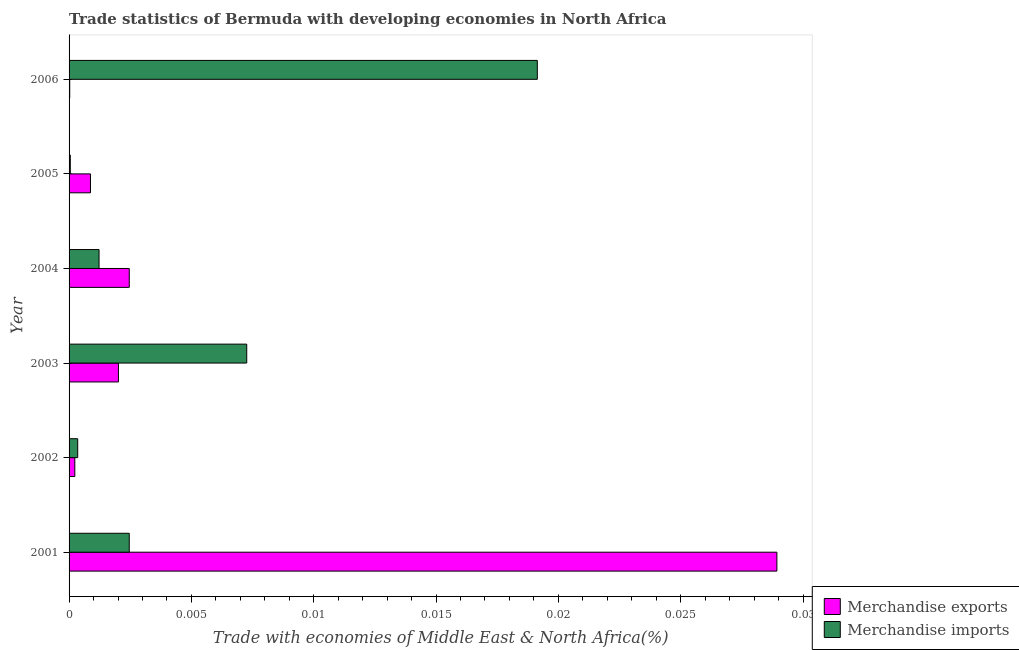How many different coloured bars are there?
Provide a short and direct response. 2. How many groups of bars are there?
Make the answer very short. 6. What is the label of the 4th group of bars from the top?
Your response must be concise. 2003. In how many cases, is the number of bars for a given year not equal to the number of legend labels?
Keep it short and to the point. 0. What is the merchandise imports in 2002?
Your answer should be compact. 0. Across all years, what is the maximum merchandise imports?
Your response must be concise. 0.02. Across all years, what is the minimum merchandise exports?
Your response must be concise. 2.670901782509311e-5. In which year was the merchandise exports minimum?
Your answer should be compact. 2006. What is the total merchandise exports in the graph?
Your response must be concise. 0.03. What is the difference between the merchandise exports in 2001 and that in 2003?
Provide a short and direct response. 0.03. What is the difference between the merchandise exports in 2001 and the merchandise imports in 2005?
Your answer should be compact. 0.03. What is the average merchandise imports per year?
Your response must be concise. 0.01. In the year 2003, what is the difference between the merchandise exports and merchandise imports?
Offer a very short reply. -0.01. In how many years, is the merchandise imports greater than 0.005 %?
Offer a very short reply. 2. What is the ratio of the merchandise imports in 2002 to that in 2006?
Provide a short and direct response. 0.02. Is the merchandise exports in 2002 less than that in 2006?
Ensure brevity in your answer.  No. Is the difference between the merchandise imports in 2004 and 2005 greater than the difference between the merchandise exports in 2004 and 2005?
Offer a terse response. No. What is the difference between the highest and the second highest merchandise imports?
Make the answer very short. 0.01. What is the difference between the highest and the lowest merchandise imports?
Provide a succinct answer. 0.02. In how many years, is the merchandise exports greater than the average merchandise exports taken over all years?
Keep it short and to the point. 1. How many bars are there?
Keep it short and to the point. 12. Are all the bars in the graph horizontal?
Your answer should be compact. Yes. How many years are there in the graph?
Ensure brevity in your answer.  6. What is the difference between two consecutive major ticks on the X-axis?
Provide a succinct answer. 0.01. Does the graph contain grids?
Provide a succinct answer. No. Where does the legend appear in the graph?
Offer a very short reply. Bottom right. What is the title of the graph?
Ensure brevity in your answer.  Trade statistics of Bermuda with developing economies in North Africa. Does "State government" appear as one of the legend labels in the graph?
Make the answer very short. No. What is the label or title of the X-axis?
Offer a terse response. Trade with economies of Middle East & North Africa(%). What is the Trade with economies of Middle East & North Africa(%) in Merchandise exports in 2001?
Provide a short and direct response. 0.03. What is the Trade with economies of Middle East & North Africa(%) of Merchandise imports in 2001?
Your response must be concise. 0. What is the Trade with economies of Middle East & North Africa(%) in Merchandise exports in 2002?
Offer a terse response. 0. What is the Trade with economies of Middle East & North Africa(%) of Merchandise imports in 2002?
Keep it short and to the point. 0. What is the Trade with economies of Middle East & North Africa(%) of Merchandise exports in 2003?
Ensure brevity in your answer.  0. What is the Trade with economies of Middle East & North Africa(%) in Merchandise imports in 2003?
Your answer should be very brief. 0.01. What is the Trade with economies of Middle East & North Africa(%) in Merchandise exports in 2004?
Offer a terse response. 0. What is the Trade with economies of Middle East & North Africa(%) of Merchandise imports in 2004?
Keep it short and to the point. 0. What is the Trade with economies of Middle East & North Africa(%) in Merchandise exports in 2005?
Your answer should be compact. 0. What is the Trade with economies of Middle East & North Africa(%) of Merchandise imports in 2005?
Make the answer very short. 4.991405699987221e-5. What is the Trade with economies of Middle East & North Africa(%) of Merchandise exports in 2006?
Your answer should be compact. 2.670901782509311e-5. What is the Trade with economies of Middle East & North Africa(%) in Merchandise imports in 2006?
Your answer should be very brief. 0.02. Across all years, what is the maximum Trade with economies of Middle East & North Africa(%) in Merchandise exports?
Your answer should be very brief. 0.03. Across all years, what is the maximum Trade with economies of Middle East & North Africa(%) of Merchandise imports?
Your answer should be compact. 0.02. Across all years, what is the minimum Trade with economies of Middle East & North Africa(%) of Merchandise exports?
Your answer should be very brief. 2.670901782509311e-5. Across all years, what is the minimum Trade with economies of Middle East & North Africa(%) of Merchandise imports?
Keep it short and to the point. 4.991405699987221e-5. What is the total Trade with economies of Middle East & North Africa(%) in Merchandise exports in the graph?
Offer a very short reply. 0.03. What is the total Trade with economies of Middle East & North Africa(%) in Merchandise imports in the graph?
Provide a short and direct response. 0.03. What is the difference between the Trade with economies of Middle East & North Africa(%) of Merchandise exports in 2001 and that in 2002?
Give a very brief answer. 0.03. What is the difference between the Trade with economies of Middle East & North Africa(%) of Merchandise imports in 2001 and that in 2002?
Keep it short and to the point. 0. What is the difference between the Trade with economies of Middle East & North Africa(%) of Merchandise exports in 2001 and that in 2003?
Your answer should be very brief. 0.03. What is the difference between the Trade with economies of Middle East & North Africa(%) of Merchandise imports in 2001 and that in 2003?
Give a very brief answer. -0. What is the difference between the Trade with economies of Middle East & North Africa(%) in Merchandise exports in 2001 and that in 2004?
Keep it short and to the point. 0.03. What is the difference between the Trade with economies of Middle East & North Africa(%) of Merchandise imports in 2001 and that in 2004?
Keep it short and to the point. 0. What is the difference between the Trade with economies of Middle East & North Africa(%) of Merchandise exports in 2001 and that in 2005?
Keep it short and to the point. 0.03. What is the difference between the Trade with economies of Middle East & North Africa(%) in Merchandise imports in 2001 and that in 2005?
Offer a terse response. 0. What is the difference between the Trade with economies of Middle East & North Africa(%) of Merchandise exports in 2001 and that in 2006?
Offer a very short reply. 0.03. What is the difference between the Trade with economies of Middle East & North Africa(%) of Merchandise imports in 2001 and that in 2006?
Provide a succinct answer. -0.02. What is the difference between the Trade with economies of Middle East & North Africa(%) in Merchandise exports in 2002 and that in 2003?
Ensure brevity in your answer.  -0. What is the difference between the Trade with economies of Middle East & North Africa(%) of Merchandise imports in 2002 and that in 2003?
Offer a terse response. -0.01. What is the difference between the Trade with economies of Middle East & North Africa(%) in Merchandise exports in 2002 and that in 2004?
Offer a terse response. -0. What is the difference between the Trade with economies of Middle East & North Africa(%) in Merchandise imports in 2002 and that in 2004?
Your response must be concise. -0. What is the difference between the Trade with economies of Middle East & North Africa(%) in Merchandise exports in 2002 and that in 2005?
Your response must be concise. -0. What is the difference between the Trade with economies of Middle East & North Africa(%) of Merchandise imports in 2002 and that in 2006?
Your answer should be very brief. -0.02. What is the difference between the Trade with economies of Middle East & North Africa(%) in Merchandise exports in 2003 and that in 2004?
Offer a terse response. -0. What is the difference between the Trade with economies of Middle East & North Africa(%) of Merchandise imports in 2003 and that in 2004?
Your response must be concise. 0.01. What is the difference between the Trade with economies of Middle East & North Africa(%) of Merchandise exports in 2003 and that in 2005?
Your answer should be very brief. 0. What is the difference between the Trade with economies of Middle East & North Africa(%) in Merchandise imports in 2003 and that in 2005?
Offer a very short reply. 0.01. What is the difference between the Trade with economies of Middle East & North Africa(%) of Merchandise exports in 2003 and that in 2006?
Your answer should be very brief. 0. What is the difference between the Trade with economies of Middle East & North Africa(%) of Merchandise imports in 2003 and that in 2006?
Make the answer very short. -0.01. What is the difference between the Trade with economies of Middle East & North Africa(%) in Merchandise exports in 2004 and that in 2005?
Your response must be concise. 0. What is the difference between the Trade with economies of Middle East & North Africa(%) in Merchandise imports in 2004 and that in 2005?
Provide a short and direct response. 0. What is the difference between the Trade with economies of Middle East & North Africa(%) in Merchandise exports in 2004 and that in 2006?
Your answer should be very brief. 0. What is the difference between the Trade with economies of Middle East & North Africa(%) in Merchandise imports in 2004 and that in 2006?
Provide a short and direct response. -0.02. What is the difference between the Trade with economies of Middle East & North Africa(%) of Merchandise exports in 2005 and that in 2006?
Offer a very short reply. 0. What is the difference between the Trade with economies of Middle East & North Africa(%) in Merchandise imports in 2005 and that in 2006?
Make the answer very short. -0.02. What is the difference between the Trade with economies of Middle East & North Africa(%) of Merchandise exports in 2001 and the Trade with economies of Middle East & North Africa(%) of Merchandise imports in 2002?
Provide a short and direct response. 0.03. What is the difference between the Trade with economies of Middle East & North Africa(%) of Merchandise exports in 2001 and the Trade with economies of Middle East & North Africa(%) of Merchandise imports in 2003?
Keep it short and to the point. 0.02. What is the difference between the Trade with economies of Middle East & North Africa(%) in Merchandise exports in 2001 and the Trade with economies of Middle East & North Africa(%) in Merchandise imports in 2004?
Offer a very short reply. 0.03. What is the difference between the Trade with economies of Middle East & North Africa(%) of Merchandise exports in 2001 and the Trade with economies of Middle East & North Africa(%) of Merchandise imports in 2005?
Your answer should be very brief. 0.03. What is the difference between the Trade with economies of Middle East & North Africa(%) of Merchandise exports in 2001 and the Trade with economies of Middle East & North Africa(%) of Merchandise imports in 2006?
Your answer should be very brief. 0.01. What is the difference between the Trade with economies of Middle East & North Africa(%) in Merchandise exports in 2002 and the Trade with economies of Middle East & North Africa(%) in Merchandise imports in 2003?
Your answer should be compact. -0.01. What is the difference between the Trade with economies of Middle East & North Africa(%) of Merchandise exports in 2002 and the Trade with economies of Middle East & North Africa(%) of Merchandise imports in 2004?
Give a very brief answer. -0. What is the difference between the Trade with economies of Middle East & North Africa(%) in Merchandise exports in 2002 and the Trade with economies of Middle East & North Africa(%) in Merchandise imports in 2005?
Ensure brevity in your answer.  0. What is the difference between the Trade with economies of Middle East & North Africa(%) in Merchandise exports in 2002 and the Trade with economies of Middle East & North Africa(%) in Merchandise imports in 2006?
Offer a terse response. -0.02. What is the difference between the Trade with economies of Middle East & North Africa(%) in Merchandise exports in 2003 and the Trade with economies of Middle East & North Africa(%) in Merchandise imports in 2004?
Make the answer very short. 0. What is the difference between the Trade with economies of Middle East & North Africa(%) of Merchandise exports in 2003 and the Trade with economies of Middle East & North Africa(%) of Merchandise imports in 2005?
Your answer should be compact. 0. What is the difference between the Trade with economies of Middle East & North Africa(%) in Merchandise exports in 2003 and the Trade with economies of Middle East & North Africa(%) in Merchandise imports in 2006?
Provide a succinct answer. -0.02. What is the difference between the Trade with economies of Middle East & North Africa(%) of Merchandise exports in 2004 and the Trade with economies of Middle East & North Africa(%) of Merchandise imports in 2005?
Make the answer very short. 0. What is the difference between the Trade with economies of Middle East & North Africa(%) in Merchandise exports in 2004 and the Trade with economies of Middle East & North Africa(%) in Merchandise imports in 2006?
Offer a terse response. -0.02. What is the difference between the Trade with economies of Middle East & North Africa(%) of Merchandise exports in 2005 and the Trade with economies of Middle East & North Africa(%) of Merchandise imports in 2006?
Give a very brief answer. -0.02. What is the average Trade with economies of Middle East & North Africa(%) in Merchandise exports per year?
Your answer should be compact. 0.01. What is the average Trade with economies of Middle East & North Africa(%) of Merchandise imports per year?
Make the answer very short. 0.01. In the year 2001, what is the difference between the Trade with economies of Middle East & North Africa(%) of Merchandise exports and Trade with economies of Middle East & North Africa(%) of Merchandise imports?
Provide a succinct answer. 0.03. In the year 2002, what is the difference between the Trade with economies of Middle East & North Africa(%) of Merchandise exports and Trade with economies of Middle East & North Africa(%) of Merchandise imports?
Give a very brief answer. -0. In the year 2003, what is the difference between the Trade with economies of Middle East & North Africa(%) of Merchandise exports and Trade with economies of Middle East & North Africa(%) of Merchandise imports?
Offer a very short reply. -0.01. In the year 2004, what is the difference between the Trade with economies of Middle East & North Africa(%) of Merchandise exports and Trade with economies of Middle East & North Africa(%) of Merchandise imports?
Your answer should be compact. 0. In the year 2005, what is the difference between the Trade with economies of Middle East & North Africa(%) in Merchandise exports and Trade with economies of Middle East & North Africa(%) in Merchandise imports?
Ensure brevity in your answer.  0. In the year 2006, what is the difference between the Trade with economies of Middle East & North Africa(%) of Merchandise exports and Trade with economies of Middle East & North Africa(%) of Merchandise imports?
Ensure brevity in your answer.  -0.02. What is the ratio of the Trade with economies of Middle East & North Africa(%) in Merchandise exports in 2001 to that in 2002?
Give a very brief answer. 123.13. What is the ratio of the Trade with economies of Middle East & North Africa(%) of Merchandise imports in 2001 to that in 2002?
Provide a short and direct response. 6.97. What is the ratio of the Trade with economies of Middle East & North Africa(%) of Merchandise exports in 2001 to that in 2003?
Your answer should be very brief. 14.34. What is the ratio of the Trade with economies of Middle East & North Africa(%) of Merchandise imports in 2001 to that in 2003?
Your answer should be compact. 0.34. What is the ratio of the Trade with economies of Middle East & North Africa(%) in Merchandise exports in 2001 to that in 2004?
Make the answer very short. 11.76. What is the ratio of the Trade with economies of Middle East & North Africa(%) in Merchandise imports in 2001 to that in 2004?
Your answer should be very brief. 2.01. What is the ratio of the Trade with economies of Middle East & North Africa(%) in Merchandise exports in 2001 to that in 2005?
Keep it short and to the point. 33.07. What is the ratio of the Trade with economies of Middle East & North Africa(%) in Merchandise imports in 2001 to that in 2005?
Provide a succinct answer. 49.28. What is the ratio of the Trade with economies of Middle East & North Africa(%) of Merchandise exports in 2001 to that in 2006?
Offer a terse response. 1083.23. What is the ratio of the Trade with economies of Middle East & North Africa(%) in Merchandise imports in 2001 to that in 2006?
Keep it short and to the point. 0.13. What is the ratio of the Trade with economies of Middle East & North Africa(%) of Merchandise exports in 2002 to that in 2003?
Ensure brevity in your answer.  0.12. What is the ratio of the Trade with economies of Middle East & North Africa(%) of Merchandise imports in 2002 to that in 2003?
Ensure brevity in your answer.  0.05. What is the ratio of the Trade with economies of Middle East & North Africa(%) in Merchandise exports in 2002 to that in 2004?
Provide a short and direct response. 0.1. What is the ratio of the Trade with economies of Middle East & North Africa(%) of Merchandise imports in 2002 to that in 2004?
Your answer should be very brief. 0.29. What is the ratio of the Trade with economies of Middle East & North Africa(%) of Merchandise exports in 2002 to that in 2005?
Your response must be concise. 0.27. What is the ratio of the Trade with economies of Middle East & North Africa(%) in Merchandise imports in 2002 to that in 2005?
Offer a terse response. 7.07. What is the ratio of the Trade with economies of Middle East & North Africa(%) of Merchandise exports in 2002 to that in 2006?
Provide a succinct answer. 8.8. What is the ratio of the Trade with economies of Middle East & North Africa(%) of Merchandise imports in 2002 to that in 2006?
Keep it short and to the point. 0.02. What is the ratio of the Trade with economies of Middle East & North Africa(%) of Merchandise exports in 2003 to that in 2004?
Ensure brevity in your answer.  0.82. What is the ratio of the Trade with economies of Middle East & North Africa(%) of Merchandise imports in 2003 to that in 2004?
Your response must be concise. 5.93. What is the ratio of the Trade with economies of Middle East & North Africa(%) in Merchandise exports in 2003 to that in 2005?
Your response must be concise. 2.31. What is the ratio of the Trade with economies of Middle East & North Africa(%) in Merchandise imports in 2003 to that in 2005?
Give a very brief answer. 145.49. What is the ratio of the Trade with economies of Middle East & North Africa(%) in Merchandise exports in 2003 to that in 2006?
Give a very brief answer. 75.54. What is the ratio of the Trade with economies of Middle East & North Africa(%) of Merchandise imports in 2003 to that in 2006?
Your response must be concise. 0.38. What is the ratio of the Trade with economies of Middle East & North Africa(%) in Merchandise exports in 2004 to that in 2005?
Give a very brief answer. 2.81. What is the ratio of the Trade with economies of Middle East & North Africa(%) in Merchandise imports in 2004 to that in 2005?
Your answer should be very brief. 24.54. What is the ratio of the Trade with economies of Middle East & North Africa(%) of Merchandise exports in 2004 to that in 2006?
Your answer should be compact. 92.12. What is the ratio of the Trade with economies of Middle East & North Africa(%) of Merchandise imports in 2004 to that in 2006?
Give a very brief answer. 0.06. What is the ratio of the Trade with economies of Middle East & North Africa(%) in Merchandise exports in 2005 to that in 2006?
Your response must be concise. 32.75. What is the ratio of the Trade with economies of Middle East & North Africa(%) of Merchandise imports in 2005 to that in 2006?
Your answer should be very brief. 0. What is the difference between the highest and the second highest Trade with economies of Middle East & North Africa(%) in Merchandise exports?
Provide a succinct answer. 0.03. What is the difference between the highest and the second highest Trade with economies of Middle East & North Africa(%) of Merchandise imports?
Offer a terse response. 0.01. What is the difference between the highest and the lowest Trade with economies of Middle East & North Africa(%) in Merchandise exports?
Provide a short and direct response. 0.03. What is the difference between the highest and the lowest Trade with economies of Middle East & North Africa(%) of Merchandise imports?
Your response must be concise. 0.02. 